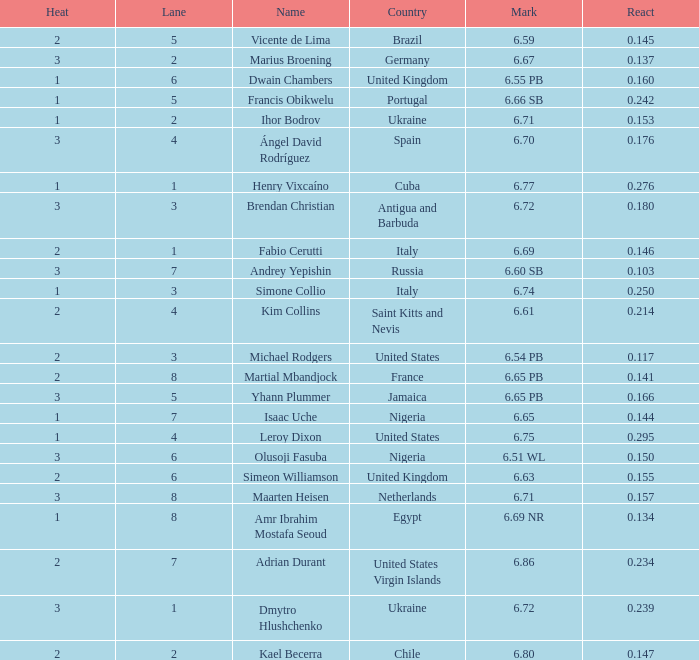What is Mark, when Name is Dmytro Hlushchenko? 6.72. 